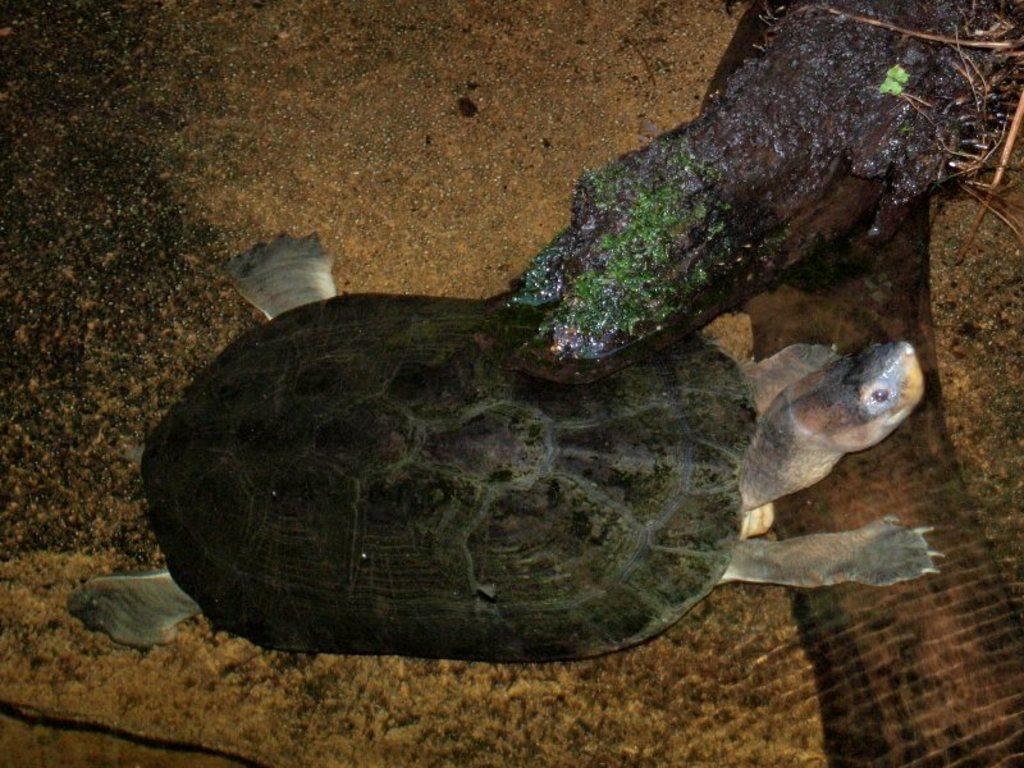What type of animal is in the water in the image? There is a tortoise and a crocodile in the water in the image. What else can be seen in the water besides the animals? The provided facts do not mention any other objects or elements in the water. What is located on the right side of the image? There is a plant on the right side of the image. What type of creature is performing on the stage in the image? There is no stage or creature performing in the image; it features a tortoise, a crocodile, and a plant. 